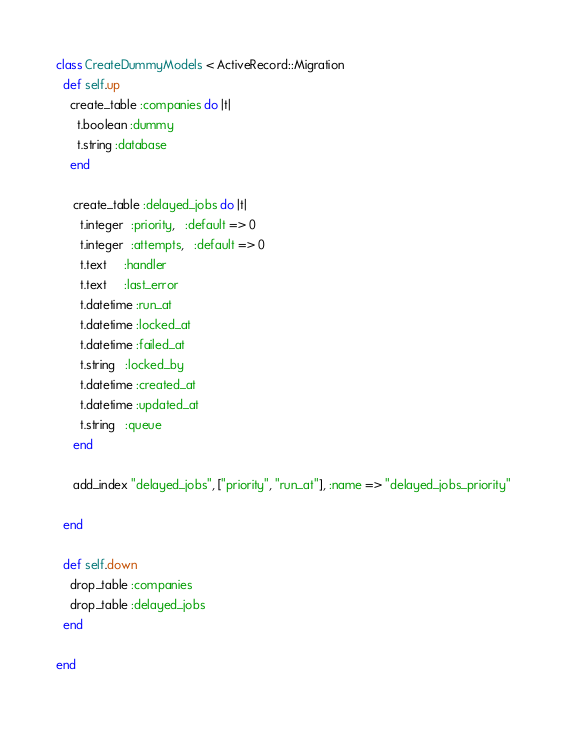<code> <loc_0><loc_0><loc_500><loc_500><_Ruby_>class CreateDummyModels < ActiveRecord::Migration
  def self.up
    create_table :companies do |t|
      t.boolean :dummy
      t.string :database
    end

     create_table :delayed_jobs do |t|
       t.integer  :priority,   :default => 0
       t.integer  :attempts,   :default => 0
       t.text     :handler
       t.text     :last_error
       t.datetime :run_at
       t.datetime :locked_at
       t.datetime :failed_at
       t.string   :locked_by
       t.datetime :created_at
       t.datetime :updated_at
       t.string   :queue
     end

     add_index "delayed_jobs", ["priority", "run_at"], :name => "delayed_jobs_priority"

  end

  def self.down
    drop_table :companies
    drop_table :delayed_jobs
  end

end
</code> 